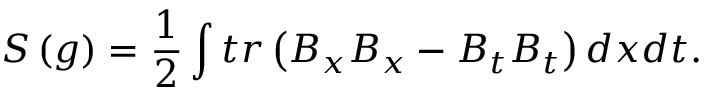<formula> <loc_0><loc_0><loc_500><loc_500>S \left ( g \right ) = \frac { 1 } { 2 } \int t r \left ( B _ { x } B _ { x } - B _ { t } B _ { t } \right ) d x d t .</formula> 